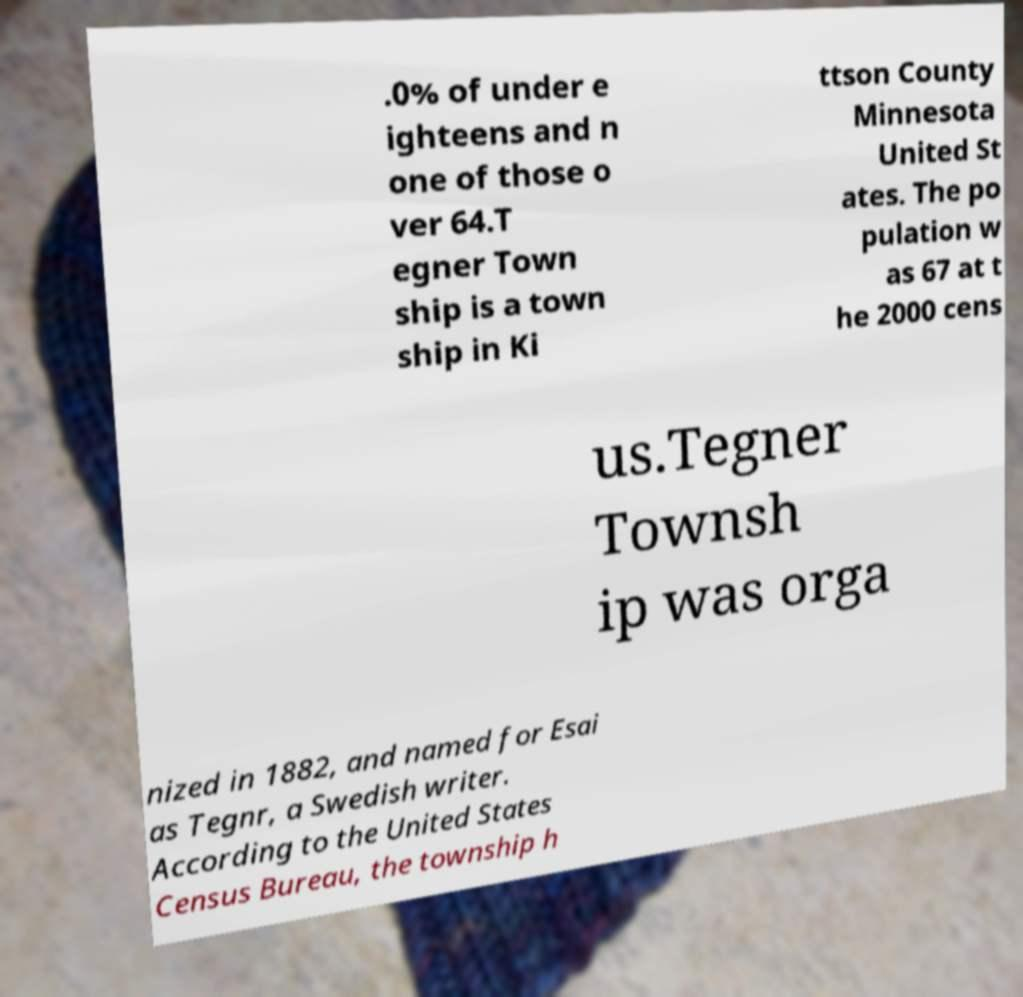Please identify and transcribe the text found in this image. .0% of under e ighteens and n one of those o ver 64.T egner Town ship is a town ship in Ki ttson County Minnesota United St ates. The po pulation w as 67 at t he 2000 cens us.Tegner Townsh ip was orga nized in 1882, and named for Esai as Tegnr, a Swedish writer. According to the United States Census Bureau, the township h 